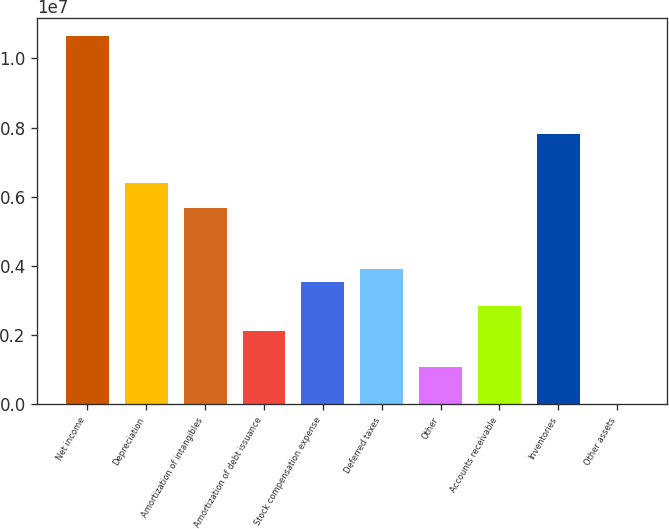<chart> <loc_0><loc_0><loc_500><loc_500><bar_chart><fcel>Net income<fcel>Depreciation<fcel>Amortization of intangibles<fcel>Amortization of debt issuance<fcel>Stock compensation expense<fcel>Deferred taxes<fcel>Other<fcel>Accounts receivable<fcel>Inventories<fcel>Other assets<nl><fcel>1.06391e+07<fcel>6.38344e+06<fcel>5.67417e+06<fcel>2.12782e+06<fcel>3.54636e+06<fcel>3.901e+06<fcel>1.06391e+06<fcel>2.83709e+06<fcel>7.80199e+06<fcel>4<nl></chart> 